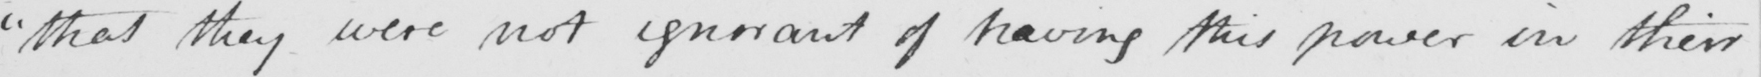What text is written in this handwritten line? " that they were not ignorant of having this power in their 